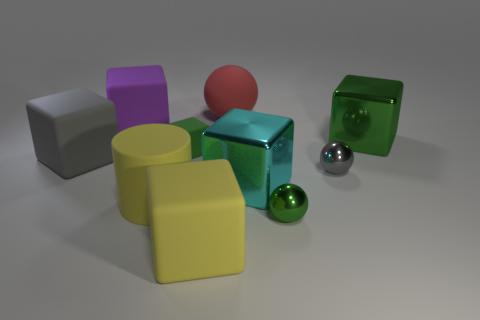Subtract 2 cubes. How many cubes are left? 4 Subtract all purple cubes. How many cubes are left? 5 Subtract all green blocks. How many blocks are left? 4 Subtract all yellow blocks. Subtract all gray balls. How many blocks are left? 5 Subtract all cylinders. How many objects are left? 9 Subtract all purple things. Subtract all blocks. How many objects are left? 3 Add 9 large red spheres. How many large red spheres are left? 10 Add 2 large brown rubber cylinders. How many large brown rubber cylinders exist? 2 Subtract 1 gray balls. How many objects are left? 9 